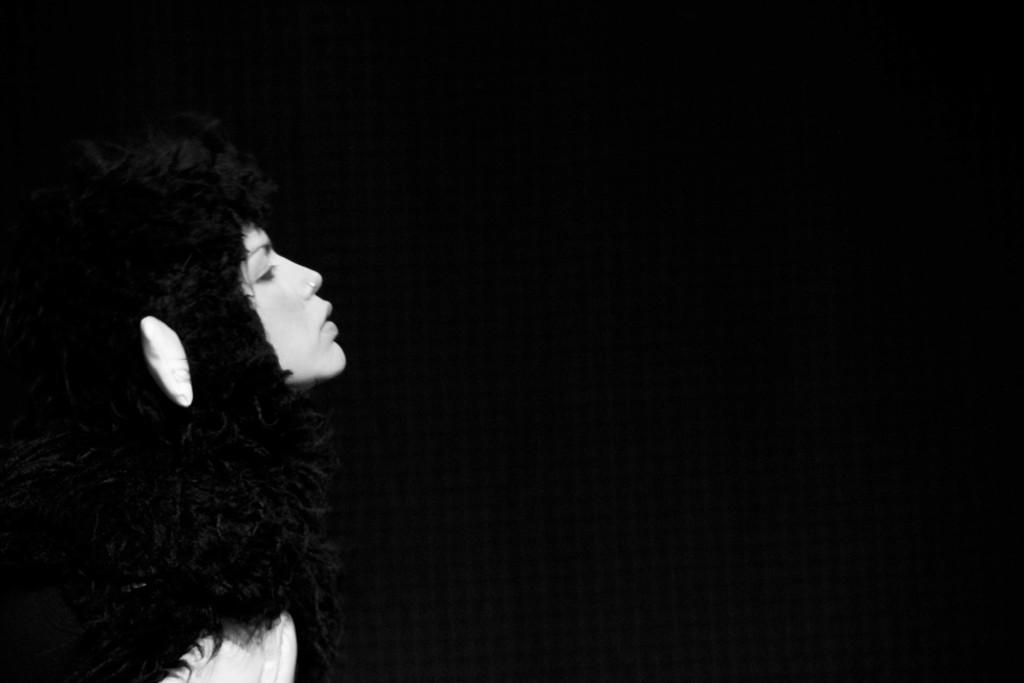Who is the main subject in the image? There is a woman in the image. Where is the woman located in the image? The woman is on the left side of the image. What can be observed about the background of the image? The background of the image is dark. What type of tomatoes can be seen growing in the woman's hair in the image? There are no tomatoes present in the image, nor are there any plants or haircuts mentioned. 